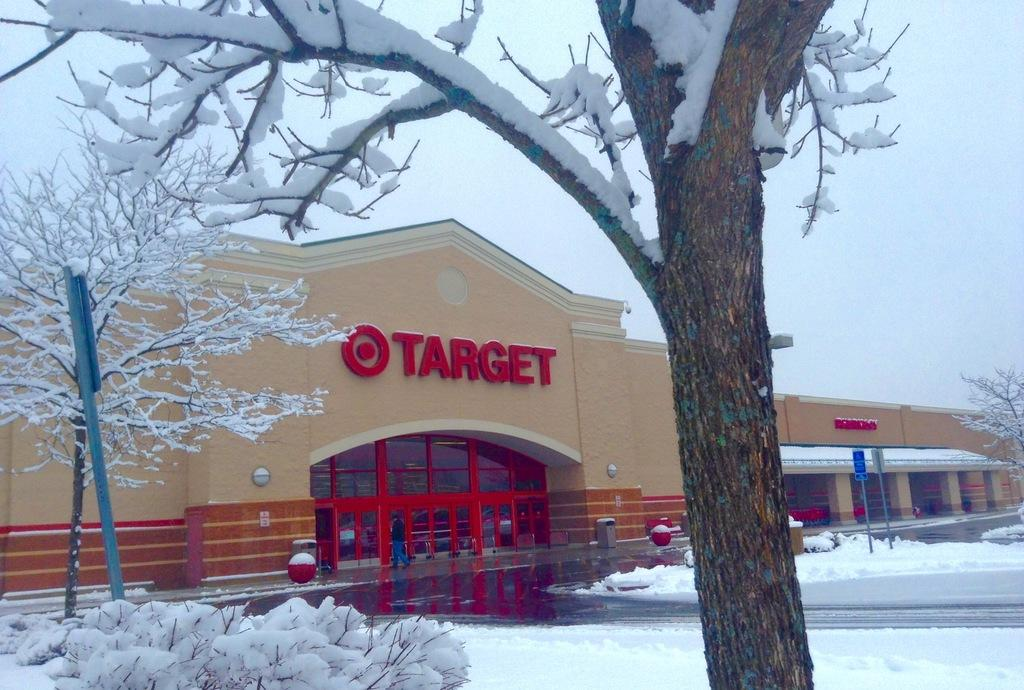What type of structure is present in the image? There is a building in the image. What objects can be seen near the building? There are poles, boards, bins, and balls visible in the image. What is the weather like in the image? There is snow visible in the image, and plants and trees are covered with snow. What can be seen in the background of the image? There is sky visible in the background of the image. Where is the doctor standing in the image? There is no doctor present in the image. What type of vase can be seen holding the flowers in the image? There are no flowers or vases present in the image. 